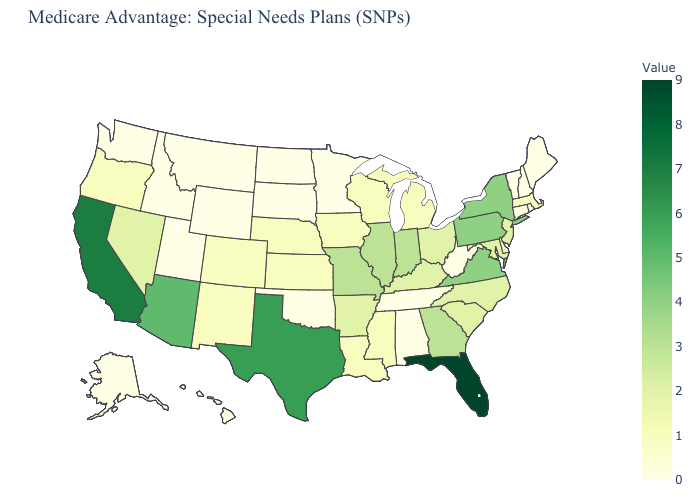Which states have the lowest value in the South?
Concise answer only. Alabama, Oklahoma, Tennessee, West Virginia. Is the legend a continuous bar?
Concise answer only. Yes. Does the map have missing data?
Concise answer only. No. Which states have the lowest value in the MidWest?
Quick response, please. Minnesota, North Dakota, South Dakota. Among the states that border Kansas , which have the lowest value?
Write a very short answer. Oklahoma. Does California have the highest value in the West?
Short answer required. Yes. 